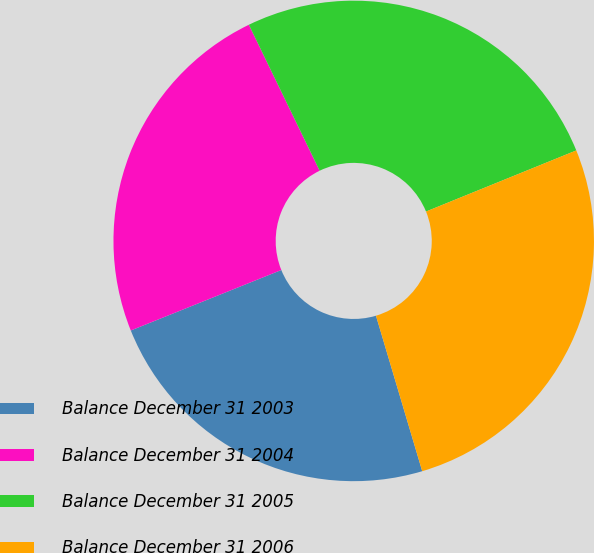<chart> <loc_0><loc_0><loc_500><loc_500><pie_chart><fcel>Balance December 31 2003<fcel>Balance December 31 2004<fcel>Balance December 31 2005<fcel>Balance December 31 2006<nl><fcel>23.52%<fcel>23.89%<fcel>26.04%<fcel>26.54%<nl></chart> 